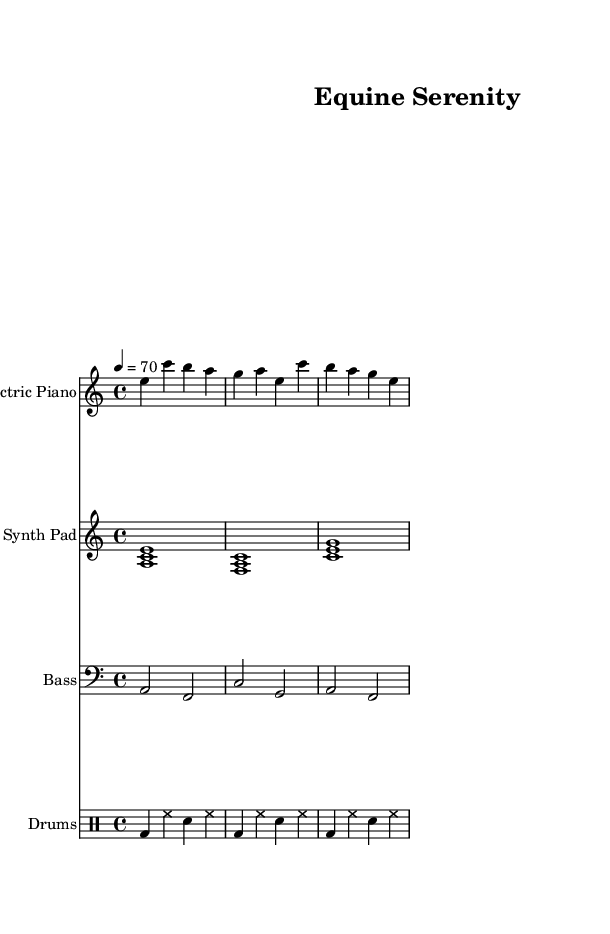What is the key signature of this music? The key signature is indicated at the beginning of the piece. In this case, it shows one flat (B♭), which indicates that the key is A minor.
Answer: A minor What is the time signature of this music? The time signature is shown at the beginning of the score, after the key signature. Here, it is marked as 4/4, which means four beats per measure.
Answer: 4/4 What is the tempo marking of this music? The tempo is indicated as “4 = 70” which means the quarter note is played at a speed of 70 beats per minute.
Answer: 70 How many instruments are indicated in this score? By examining the score, we can see four staves, each representing a different instrument: Electric Piano, Synth Pad, Bass, and Drums.
Answer: Four What is the primary instrument used to play the melody? The melody is mainly presented in the Electric Piano staff, where the notes are explicitly written and highlighted.
Answer: Electric Piano What are the drum components included in this piece? The drum pattern consists of bass drum (bd), hi-hat (hh), and snare drum (sn). These elements create the rhythmic foundation for the piece.
Answer: Bass drum, hi-hat, snare drum What is the structure of the synth pad section in terms of chords? The synth pad section includes a sequence of triads, such as <a c e>, <f a c>, and <c' e g>, which indicates it uses chords that are foundational to electronic harmony.
Answer: Triads 